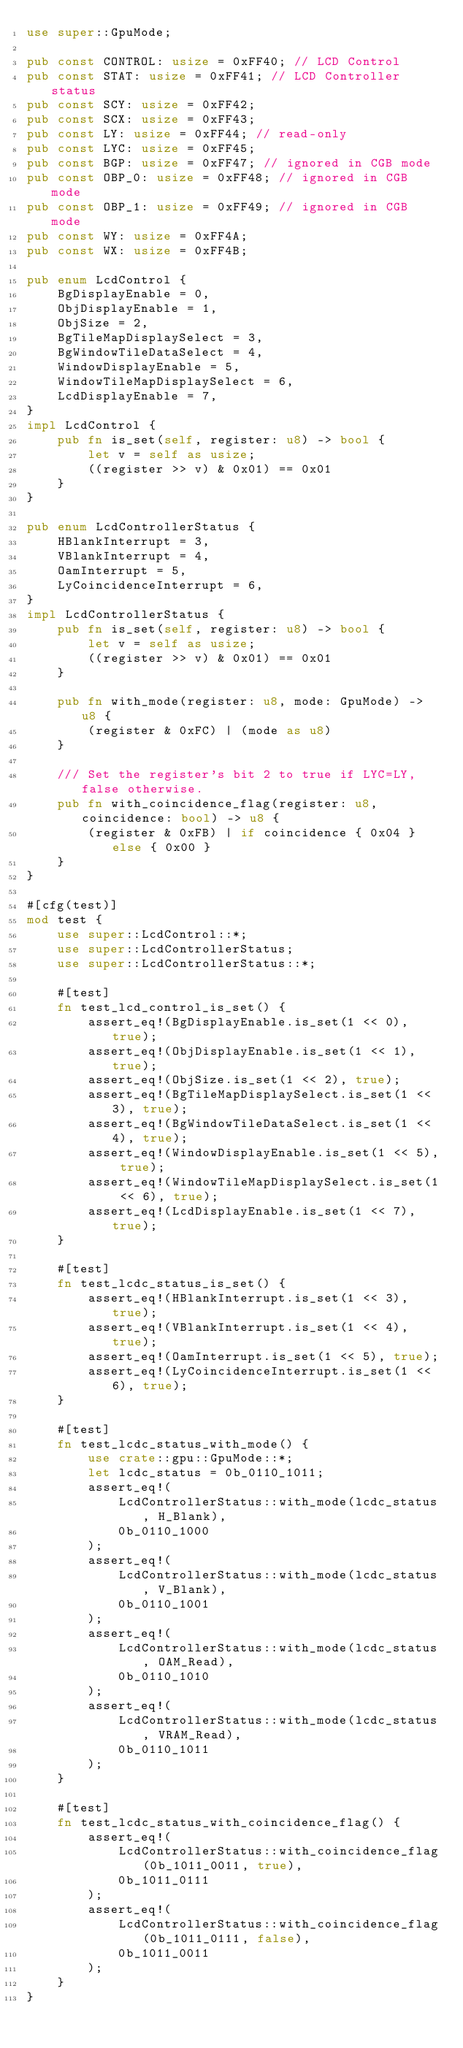<code> <loc_0><loc_0><loc_500><loc_500><_Rust_>use super::GpuMode;

pub const CONTROL: usize = 0xFF40; // LCD Control
pub const STAT: usize = 0xFF41; // LCD Controller status
pub const SCY: usize = 0xFF42;
pub const SCX: usize = 0xFF43;
pub const LY: usize = 0xFF44; // read-only
pub const LYC: usize = 0xFF45;
pub const BGP: usize = 0xFF47; // ignored in CGB mode
pub const OBP_0: usize = 0xFF48; // ignored in CGB mode
pub const OBP_1: usize = 0xFF49; // ignored in CGB mode
pub const WY: usize = 0xFF4A;
pub const WX: usize = 0xFF4B;

pub enum LcdControl {
    BgDisplayEnable = 0,
    ObjDisplayEnable = 1,
    ObjSize = 2,
    BgTileMapDisplaySelect = 3,
    BgWindowTileDataSelect = 4,
    WindowDisplayEnable = 5,
    WindowTileMapDisplaySelect = 6,
    LcdDisplayEnable = 7,
}
impl LcdControl {
    pub fn is_set(self, register: u8) -> bool {
        let v = self as usize;
        ((register >> v) & 0x01) == 0x01
    }
}

pub enum LcdControllerStatus {
    HBlankInterrupt = 3,
    VBlankInterrupt = 4,
    OamInterrupt = 5,
    LyCoincidenceInterrupt = 6,
}
impl LcdControllerStatus {
    pub fn is_set(self, register: u8) -> bool {
        let v = self as usize;
        ((register >> v) & 0x01) == 0x01
    }

    pub fn with_mode(register: u8, mode: GpuMode) -> u8 {
        (register & 0xFC) | (mode as u8)
    }

    /// Set the register's bit 2 to true if LYC=LY, false otherwise.
    pub fn with_coincidence_flag(register: u8, coincidence: bool) -> u8 {
        (register & 0xFB) | if coincidence { 0x04 } else { 0x00 }
    }
}

#[cfg(test)]
mod test {
    use super::LcdControl::*;
    use super::LcdControllerStatus;
    use super::LcdControllerStatus::*;

    #[test]
    fn test_lcd_control_is_set() {
        assert_eq!(BgDisplayEnable.is_set(1 << 0), true);
        assert_eq!(ObjDisplayEnable.is_set(1 << 1), true);
        assert_eq!(ObjSize.is_set(1 << 2), true);
        assert_eq!(BgTileMapDisplaySelect.is_set(1 << 3), true);
        assert_eq!(BgWindowTileDataSelect.is_set(1 << 4), true);
        assert_eq!(WindowDisplayEnable.is_set(1 << 5), true);
        assert_eq!(WindowTileMapDisplaySelect.is_set(1 << 6), true);
        assert_eq!(LcdDisplayEnable.is_set(1 << 7), true);
    }

    #[test]
    fn test_lcdc_status_is_set() {
        assert_eq!(HBlankInterrupt.is_set(1 << 3), true);
        assert_eq!(VBlankInterrupt.is_set(1 << 4), true);
        assert_eq!(OamInterrupt.is_set(1 << 5), true);
        assert_eq!(LyCoincidenceInterrupt.is_set(1 << 6), true);
    }

    #[test]
    fn test_lcdc_status_with_mode() {
        use crate::gpu::GpuMode::*;
        let lcdc_status = 0b_0110_1011;
        assert_eq!(
            LcdControllerStatus::with_mode(lcdc_status, H_Blank),
            0b_0110_1000
        );
        assert_eq!(
            LcdControllerStatus::with_mode(lcdc_status, V_Blank),
            0b_0110_1001
        );
        assert_eq!(
            LcdControllerStatus::with_mode(lcdc_status, OAM_Read),
            0b_0110_1010
        );
        assert_eq!(
            LcdControllerStatus::with_mode(lcdc_status, VRAM_Read),
            0b_0110_1011
        );
    }

    #[test]
    fn test_lcdc_status_with_coincidence_flag() {
        assert_eq!(
            LcdControllerStatus::with_coincidence_flag(0b_1011_0011, true),
            0b_1011_0111
        );
        assert_eq!(
            LcdControllerStatus::with_coincidence_flag(0b_1011_0111, false),
            0b_1011_0011
        );
    }
}
</code> 